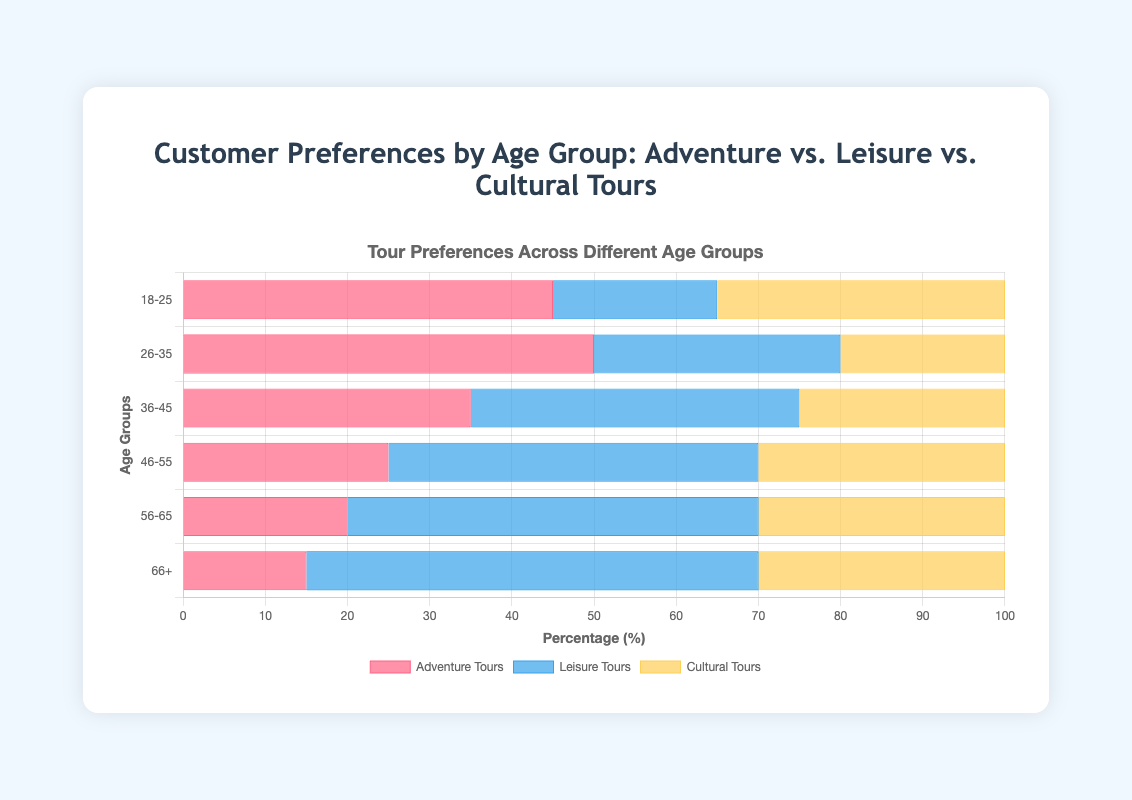Which age group prefers Adventure Tours the most? By looking at the horizontal bars representing Adventure Tours, the bar for the 26-35 age group is the longest, indicating the highest preference.
Answer: 26-35 Which age group prefers Leisure Tours the least? By observing the length of the horizontal bars for Leisure Tours, the shortest bar corresponds to the 18-25 age group.
Answer: 18-25 Between the 36-45 and 46-55 age groups, which one has a higher preference for Cultural Tours? Comparing the lengths of the bars for Cultural Tours, the 46-55 age group has a longer bar than the 36-45 age group.
Answer: 46-55 What is the total preference percentage for Adventure Tours and Cultural Tours in the 18-25 age group? The preferences for the 18-25 age group are 45% for Adventure Tours and 35% for Cultural Tours. Adding these percentages gives 45 + 35 = 80%.
Answer: 80% Which tour type is most preferred by the 56-65 age group? By examining the 56-65 age group bars, the Leisure Tours bar is the longest among the three types.
Answer: Leisure Tours How does the preference for Adventure Tours change from the 18-25 age group to the 66+ age group? Comparing the lengths of the Adventure Tours bars, the preference decreases from 45% in the 18-25 age group to 15% in the 66+ age group.
Answer: Decreases For the 26-35 age group, what is the difference in preference between Adventure Tours and Cultural Tours? The 26-35 age group has 50% preference for Adventure Tours and 20% for Cultural Tours. The difference is 50 - 20 = 30%.
Answer: 30% In which age group is the preference for Leisure Tours closest to 50%? Looking at the horizontal bars for Leisure Tours, the 56-65 and 66+ age groups both have bars very close to 50%, with slight differences.
Answer: 56-65 and 66+ What is the average preference for Cultural Tours across all age groups? The preferences for Cultural Tours are 35, 20, 25, 30, 30, and 30 for each age group respectively. The sum is 35 + 20 + 25 + 30 + 30 + 30 = 170, and there are 6 age groups. The average is 170 / 6 ≈ 28.3%.
Answer: 28.3% Which tour type shows a decreasing trend in preference as age increases? Analyzing the bars, Adventure Tours show a decreasing trend in preference from younger to older age groups.
Answer: Adventure Tours 